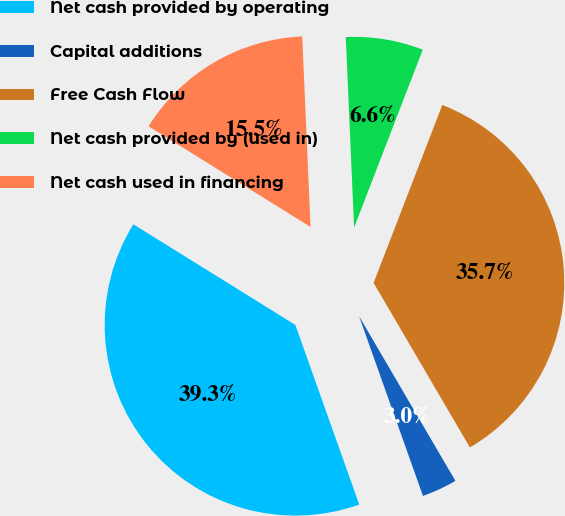Convert chart to OTSL. <chart><loc_0><loc_0><loc_500><loc_500><pie_chart><fcel>Net cash provided by operating<fcel>Capital additions<fcel>Free Cash Flow<fcel>Net cash provided by (used in)<fcel>Net cash used in financing<nl><fcel>39.28%<fcel>2.99%<fcel>35.71%<fcel>6.56%<fcel>15.46%<nl></chart> 